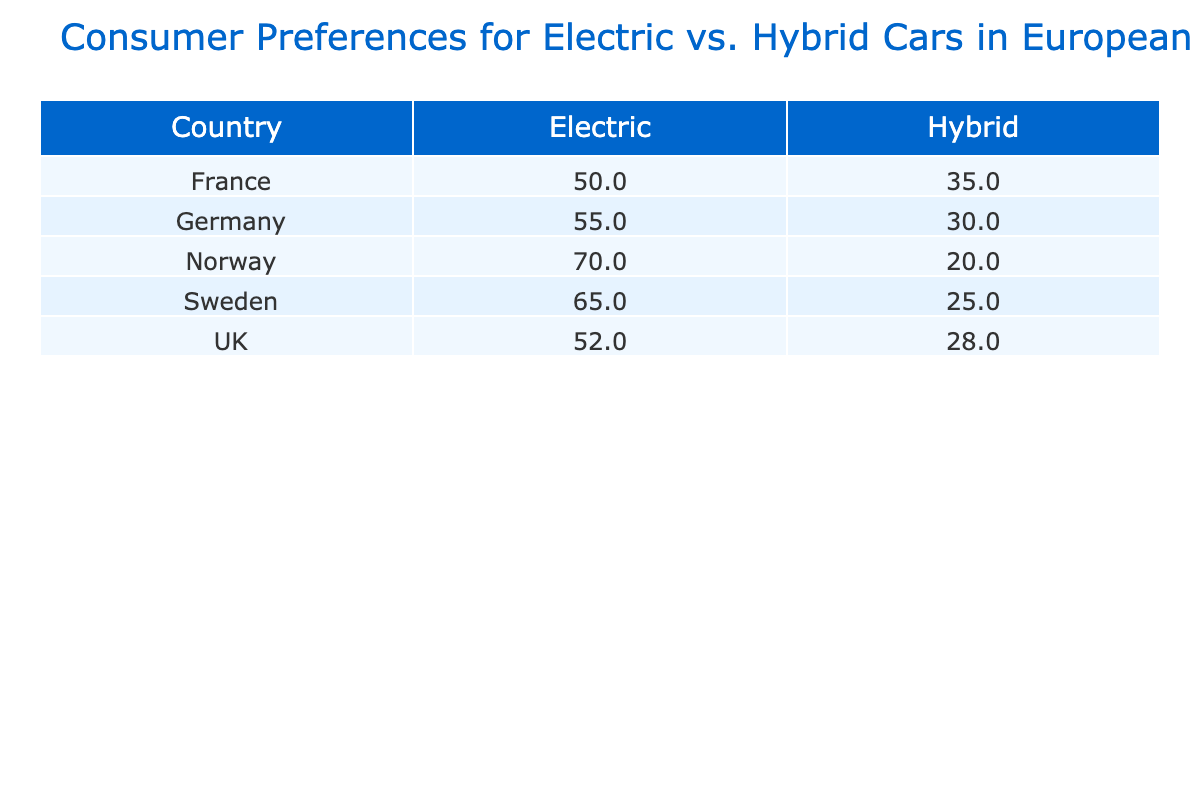What is the preference percentage for electric cars in Germany? Referring to the table, Germany's preference percentage for electric cars is explicitly listed. The data shows that the percentage for Electric in Germany is 55.
Answer: 55 What is the preference percentage for hybrid cars in Sweden? Looking at the table, Sweden's preference for hybrid cars can be found directly. The preference percentage for Hybrid in Sweden is 25.
Answer: 25 Which country has the highest preference for electric cars? The table allows for a comparison across countries. Norway has the highest preference percentage for electric cars at 70.
Answer: Norway What is the total percentage of preference for electric cars across all countries? To find the total, we add the individual percentages for electric cars: 65 (Sweden) + 70 (Norway) + 55 (Germany) + 50 (France) + 52 (UK) = 292.
Answer: 292 Is the preference for hybrid cars higher in France than in the UK? By examining the table, France has a preference of 35 for hybrid cars while the UK has a preference of 28. Since 35 is greater than 28, the answer is yes.
Answer: Yes What is the difference in preference percentage between electric cars in Norway and hybrid cars in Norway? The preference percentage for electric cars in Norway is 70 and for hybrid cars in Norway is 20. The difference is calculated as 70 - 20 = 50.
Answer: 50 Which country's consumers prefer electric cars the least? By comparing the electric car preference percentages, France has the lowest at 50 when considering all listed countries.
Answer: France What is the average preference percentage for hybrid cars across the five countries? To find the average, we total the hybrid preference percentages: 25 (Sweden) + 20 (Norway) + 30 (Germany) + 35 (France) + 28 (UK) = 138. Dividing by the number of countries (5) gives 138 / 5 = 27.6.
Answer: 27.6 Are consumers in Germany more inclined towards electric or hybrid cars based on their preference percentages? In the table, Germany shows a preference of 55 for electric and 30 for hybrid cars. Since 55 is greater than 30, the answer is electric.
Answer: Electric 